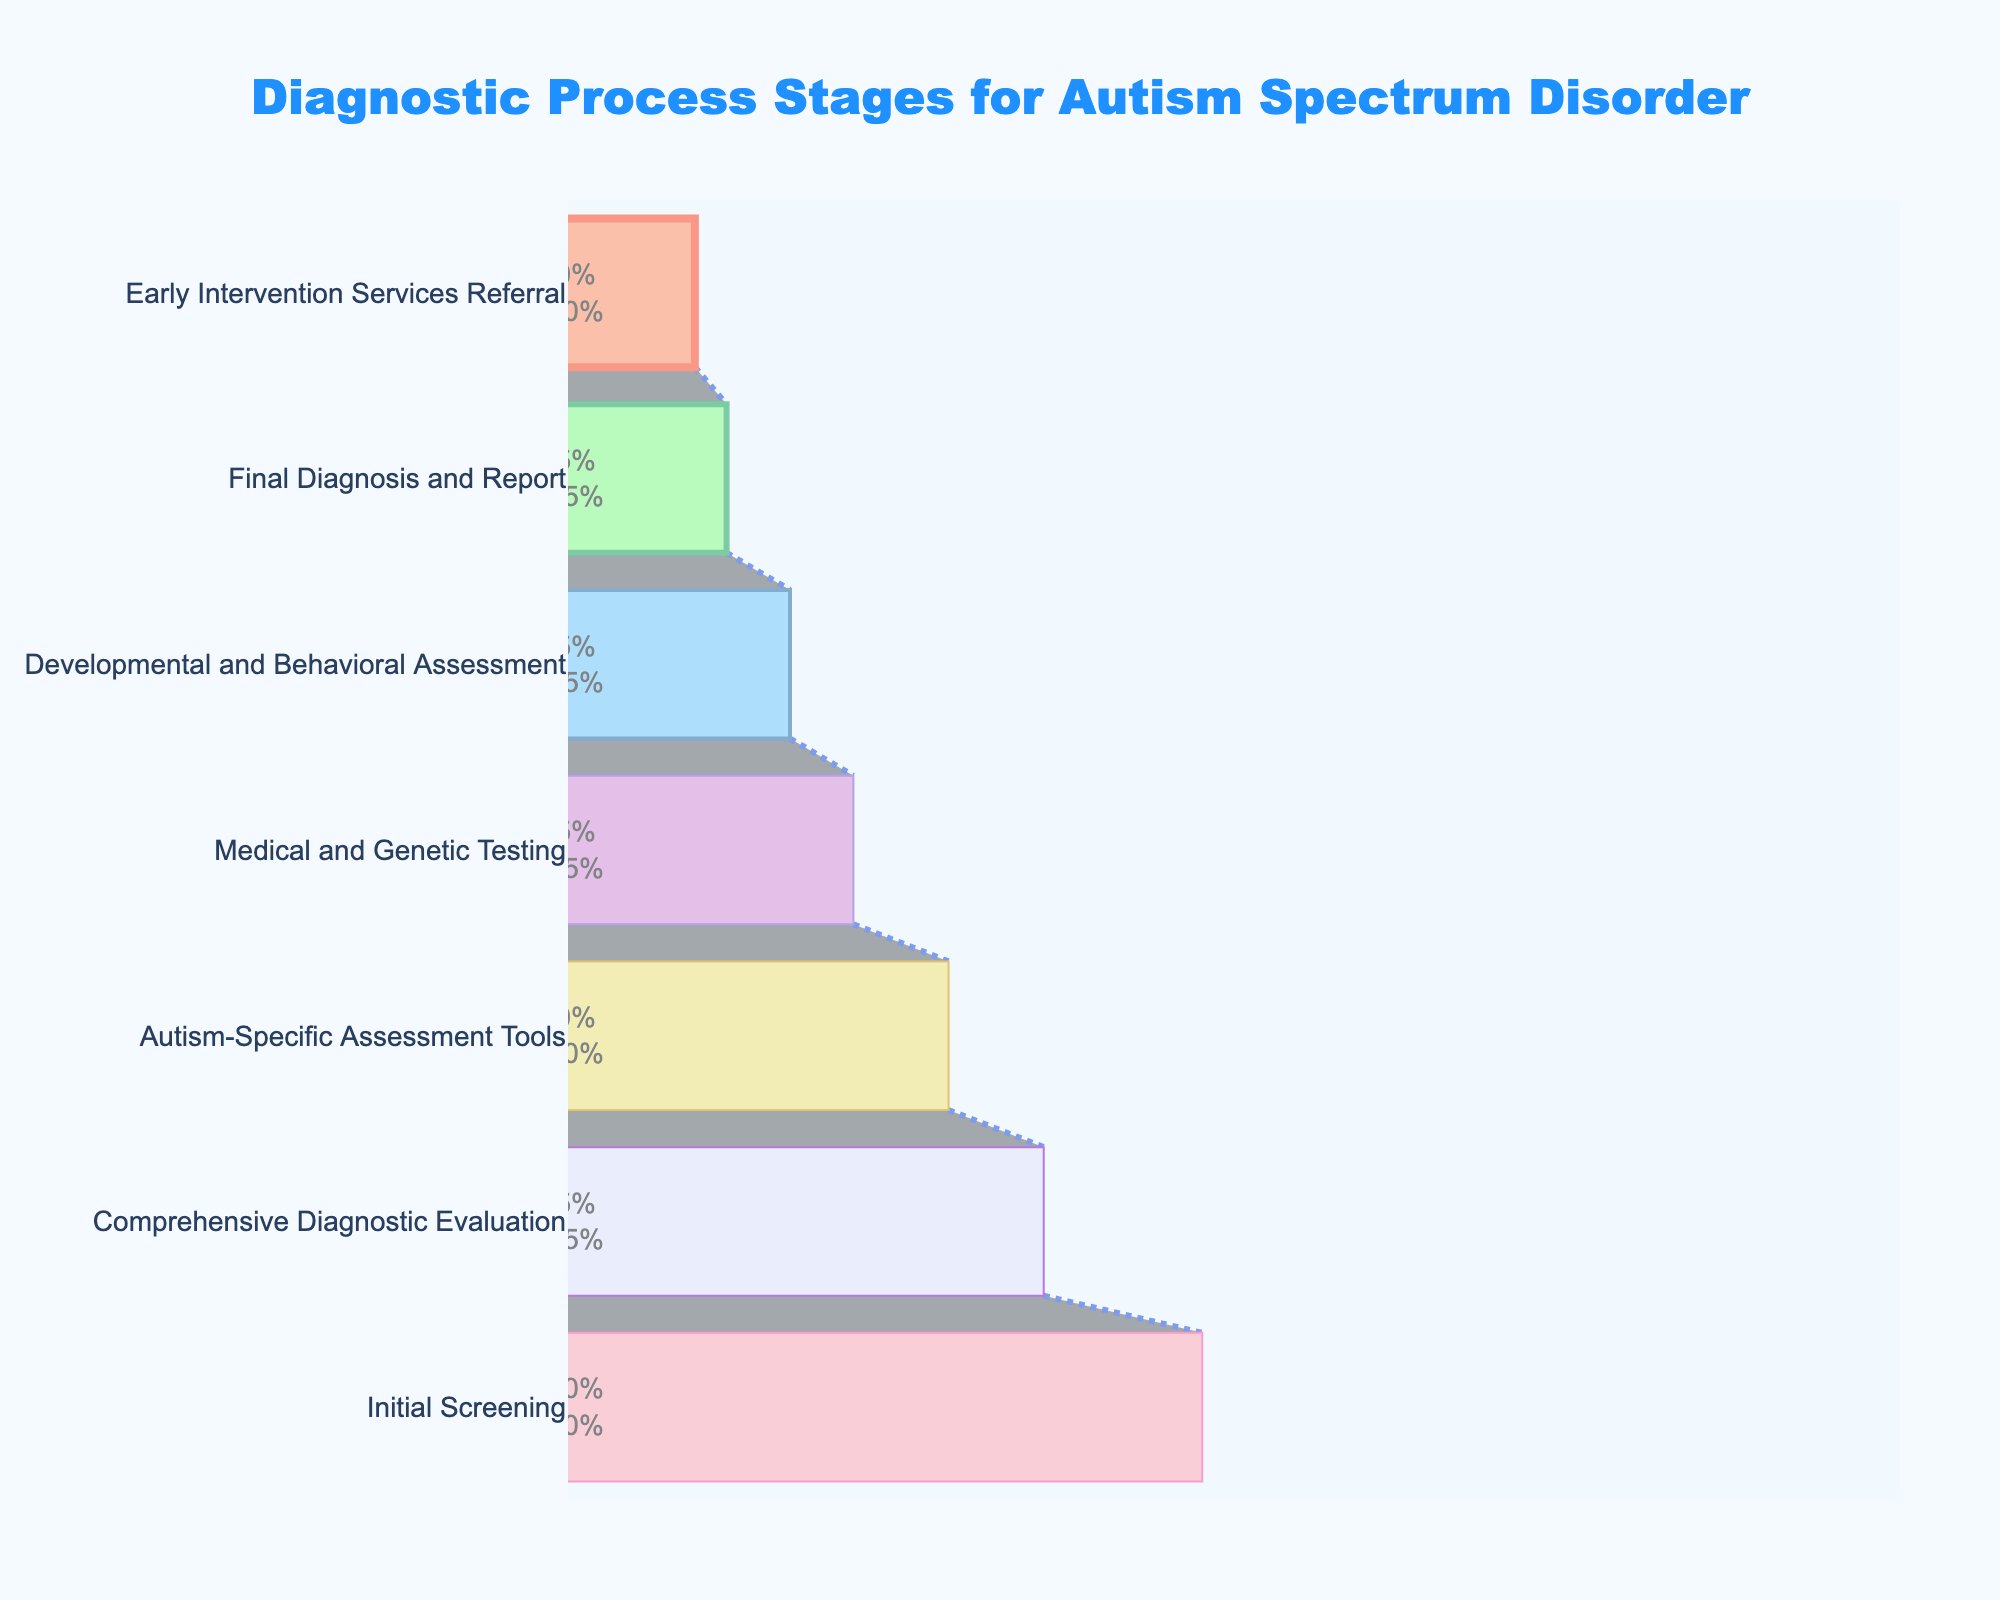How many stages are included in the diagnostic process for autism spectrum disorder? The title of the funnel chart indicates it represents diagnostic process stages, and there are seven banded stages listed in the chart.
Answer: Seven What is the title of the funnel chart? The title is clearly written at the top of the funnel chart in bold and large font size.
Answer: Diagnostic Process Stages for Autism Spectrum Disorder Which stage has the highest percentage of children? The first band at the top of the funnel chart represents the "Initial Screening" stage, which has the largest width corresponding to a percentage value of 100%.
Answer: Initial Screening How many percentage points drop from the 'Medical and Genetic Testing' stage to the 'Developmental and Behavioral Assessment' stage? The percentage value at the 'Medical and Genetic Testing' stage is 45% and at the 'Developmental and Behavioral Assessment' stage is 35%. The difference is 45% - 35%.
Answer: 10 percentage points Which stages have percentages above 50%? The funnel chart shows values decreasing from top to bottom. Only the top three stages, 'Initial Screening' (100%), 'Comprehensive Diagnostic Evaluation' (75%), and 'Autism-Specific Assessment Tools' (60%) are over 50%.
Answer: Initial Screening, Comprehensive Diagnostic Evaluation, Autism-Specific Assessment Tools What percentage of children reach the 'Early Intervention Services Referral' stage? The funnel chart lists 'Early Intervention Services Referral' near the bottom with a corresponding percentage displayed in the band.
Answer: 20% What is the difference between the highest and lowest percentage stages? The highest percentage is 100% (Initial Screening) and the lowest is 20% (Early Intervention Services Referral). Subtract the lowest from the highest: 100% - 20%.
Answer: 80% How many stages experience a drop of more than 20 percentage points from the previous stage? By examining the percentage drop between consecutive stages: Initial Screening to Comprehensive Diagnostic Evaluation (25%), Comprehensive Diagnostic Evaluation to Autism-Specific Assessment Tools (15%), Autism-Specific Assessment Tools to Medical and Genetic Testing (15%), Medical and Genetic Testing to Developmental and Behavioral Assessment (10%), Developmental and Behavioral Assessment to Final Diagnosis and Report (10%), and Final Diagnosis and Report to Early Intervention Services Referral (5%). Only the first drop is greater than 20 percentage points.
Answer: One What color represents the 'Final Diagnosis and Report' stage in the chart? The funnel chart uses different colors for each stage, with the 'Final Diagnosis and Report' stage being represented by a shade of light lavender or purple.
Answer: Light Lavender 